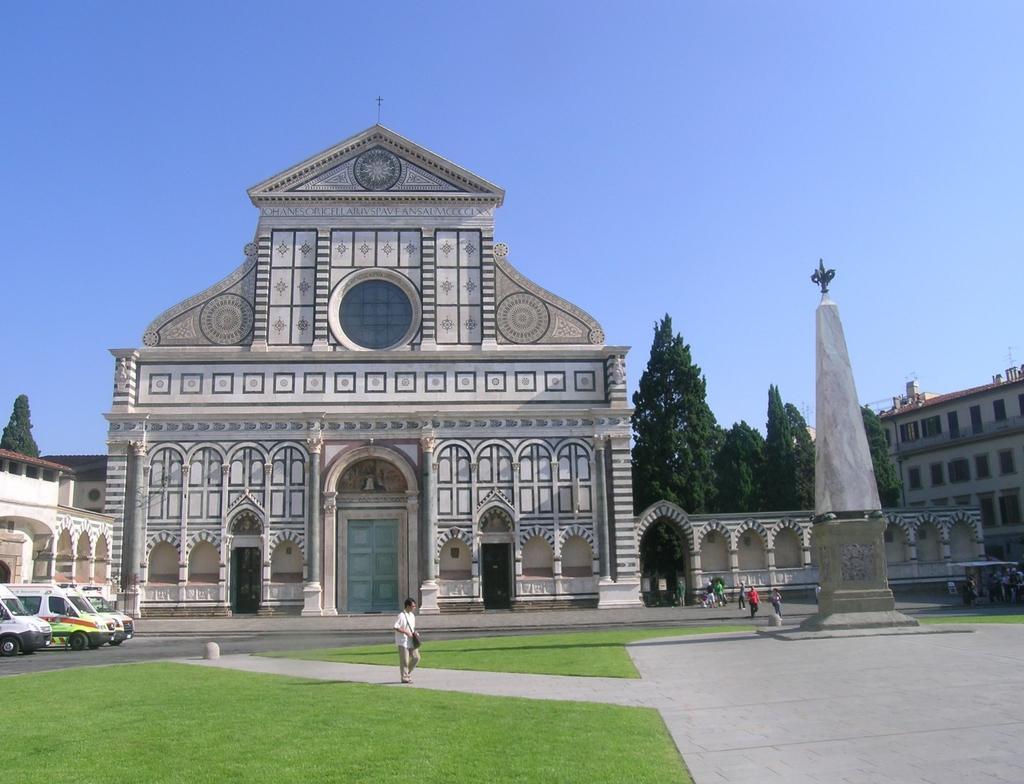Could you give a brief overview of what you see in this image? There is a building and there are few persons in front of it and there are few vehicles in the left corner and there are trees and a obelisk in the right corner. 